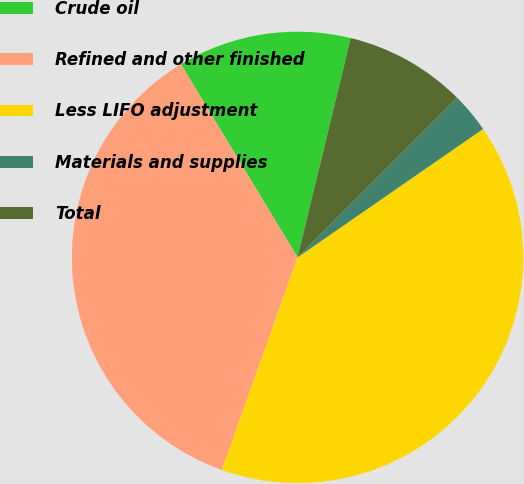Convert chart. <chart><loc_0><loc_0><loc_500><loc_500><pie_chart><fcel>Crude oil<fcel>Refined and other finished<fcel>Less LIFO adjustment<fcel>Materials and supplies<fcel>Total<nl><fcel>12.43%<fcel>35.91%<fcel>40.08%<fcel>2.87%<fcel>8.71%<nl></chart> 